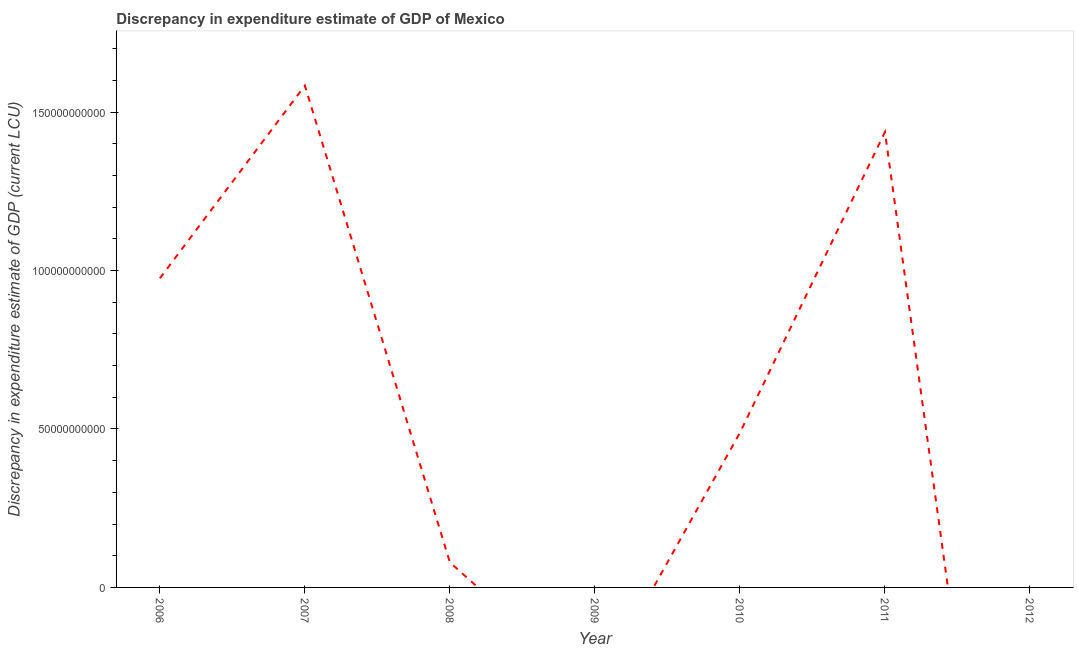What is the discrepancy in expenditure estimate of gdp in 2010?
Your response must be concise. 4.88e+1. Across all years, what is the maximum discrepancy in expenditure estimate of gdp?
Keep it short and to the point. 1.58e+11. Across all years, what is the minimum discrepancy in expenditure estimate of gdp?
Your answer should be compact. 0. In which year was the discrepancy in expenditure estimate of gdp maximum?
Keep it short and to the point. 2007. What is the sum of the discrepancy in expenditure estimate of gdp?
Offer a very short reply. 4.56e+11. What is the difference between the discrepancy in expenditure estimate of gdp in 2006 and 2010?
Give a very brief answer. 4.87e+1. What is the average discrepancy in expenditure estimate of gdp per year?
Ensure brevity in your answer.  6.52e+1. What is the median discrepancy in expenditure estimate of gdp?
Offer a terse response. 4.88e+1. What is the ratio of the discrepancy in expenditure estimate of gdp in 2006 to that in 2008?
Your answer should be compact. 12.33. Is the difference between the discrepancy in expenditure estimate of gdp in 2006 and 2011 greater than the difference between any two years?
Offer a very short reply. No. What is the difference between the highest and the second highest discrepancy in expenditure estimate of gdp?
Your response must be concise. 1.46e+1. What is the difference between the highest and the lowest discrepancy in expenditure estimate of gdp?
Offer a terse response. 1.58e+11. How many lines are there?
Offer a terse response. 1. How many years are there in the graph?
Your response must be concise. 7. Are the values on the major ticks of Y-axis written in scientific E-notation?
Provide a short and direct response. No. What is the title of the graph?
Your response must be concise. Discrepancy in expenditure estimate of GDP of Mexico. What is the label or title of the X-axis?
Provide a succinct answer. Year. What is the label or title of the Y-axis?
Make the answer very short. Discrepancy in expenditure estimate of GDP (current LCU). What is the Discrepancy in expenditure estimate of GDP (current LCU) in 2006?
Provide a succinct answer. 9.75e+1. What is the Discrepancy in expenditure estimate of GDP (current LCU) in 2007?
Make the answer very short. 1.58e+11. What is the Discrepancy in expenditure estimate of GDP (current LCU) in 2008?
Your response must be concise. 7.91e+09. What is the Discrepancy in expenditure estimate of GDP (current LCU) of 2010?
Make the answer very short. 4.88e+1. What is the Discrepancy in expenditure estimate of GDP (current LCU) of 2011?
Keep it short and to the point. 1.44e+11. What is the Discrepancy in expenditure estimate of GDP (current LCU) of 2012?
Offer a terse response. 0. What is the difference between the Discrepancy in expenditure estimate of GDP (current LCU) in 2006 and 2007?
Provide a short and direct response. -6.08e+1. What is the difference between the Discrepancy in expenditure estimate of GDP (current LCU) in 2006 and 2008?
Make the answer very short. 8.96e+1. What is the difference between the Discrepancy in expenditure estimate of GDP (current LCU) in 2006 and 2010?
Give a very brief answer. 4.87e+1. What is the difference between the Discrepancy in expenditure estimate of GDP (current LCU) in 2006 and 2011?
Provide a succinct answer. -4.62e+1. What is the difference between the Discrepancy in expenditure estimate of GDP (current LCU) in 2007 and 2008?
Your answer should be very brief. 1.50e+11. What is the difference between the Discrepancy in expenditure estimate of GDP (current LCU) in 2007 and 2010?
Keep it short and to the point. 1.10e+11. What is the difference between the Discrepancy in expenditure estimate of GDP (current LCU) in 2007 and 2011?
Ensure brevity in your answer.  1.46e+1. What is the difference between the Discrepancy in expenditure estimate of GDP (current LCU) in 2008 and 2010?
Keep it short and to the point. -4.09e+1. What is the difference between the Discrepancy in expenditure estimate of GDP (current LCU) in 2008 and 2011?
Provide a succinct answer. -1.36e+11. What is the difference between the Discrepancy in expenditure estimate of GDP (current LCU) in 2010 and 2011?
Your answer should be very brief. -9.49e+1. What is the ratio of the Discrepancy in expenditure estimate of GDP (current LCU) in 2006 to that in 2007?
Keep it short and to the point. 0.62. What is the ratio of the Discrepancy in expenditure estimate of GDP (current LCU) in 2006 to that in 2008?
Provide a short and direct response. 12.33. What is the ratio of the Discrepancy in expenditure estimate of GDP (current LCU) in 2006 to that in 2010?
Your answer should be very brief. 2. What is the ratio of the Discrepancy in expenditure estimate of GDP (current LCU) in 2006 to that in 2011?
Ensure brevity in your answer.  0.68. What is the ratio of the Discrepancy in expenditure estimate of GDP (current LCU) in 2007 to that in 2008?
Ensure brevity in your answer.  20.02. What is the ratio of the Discrepancy in expenditure estimate of GDP (current LCU) in 2007 to that in 2010?
Make the answer very short. 3.24. What is the ratio of the Discrepancy in expenditure estimate of GDP (current LCU) in 2007 to that in 2011?
Your answer should be very brief. 1.1. What is the ratio of the Discrepancy in expenditure estimate of GDP (current LCU) in 2008 to that in 2010?
Ensure brevity in your answer.  0.16. What is the ratio of the Discrepancy in expenditure estimate of GDP (current LCU) in 2008 to that in 2011?
Your response must be concise. 0.06. What is the ratio of the Discrepancy in expenditure estimate of GDP (current LCU) in 2010 to that in 2011?
Your answer should be very brief. 0.34. 